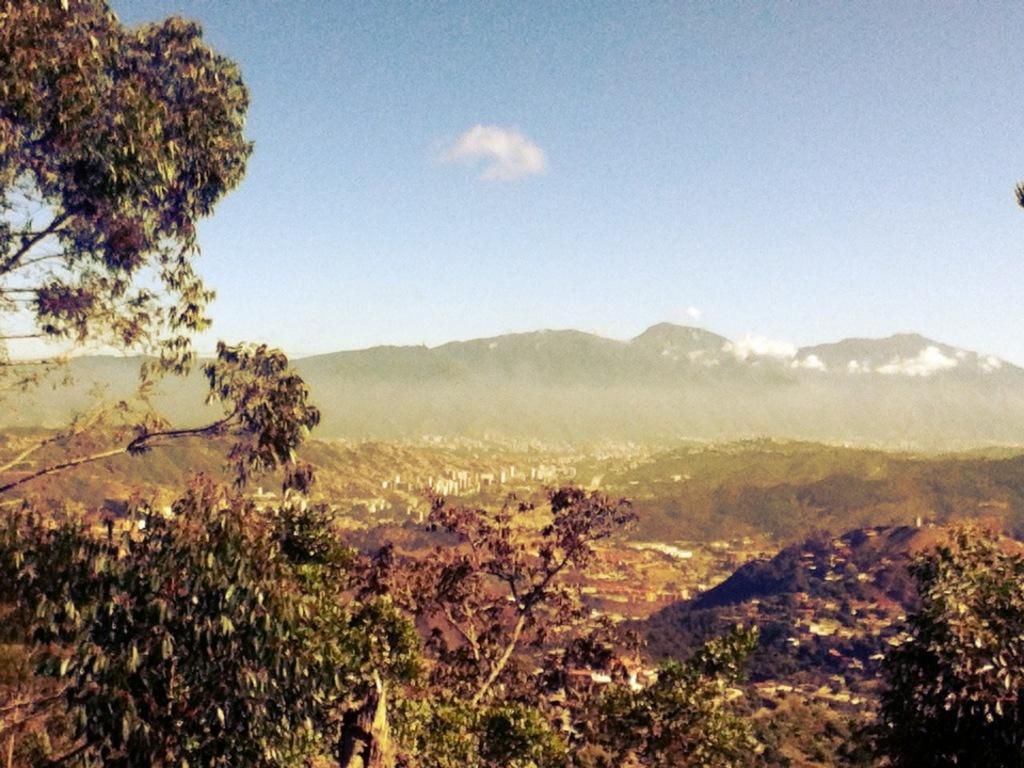Describe this image in one or two sentences. In this picture we can see some trees in the front, in the background there are hills, we can see the sky at the top of the picture. 